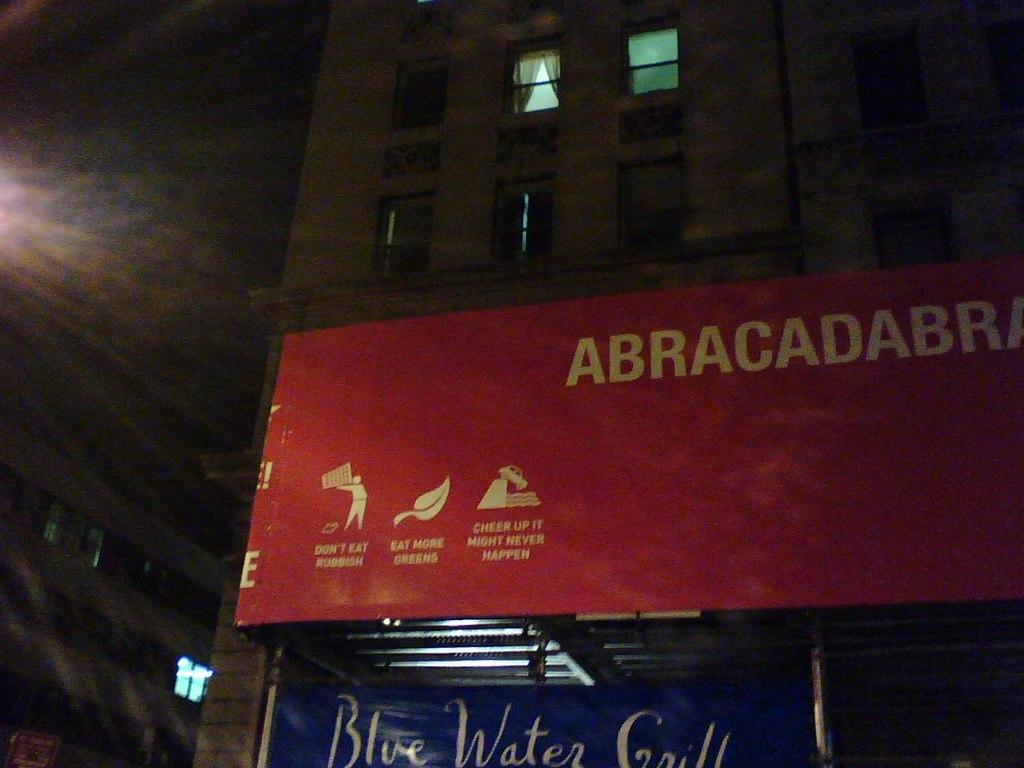What color is the water grill?
Your response must be concise. Blue. What are the three things on the bottom left corner that the red billboard tells you?
Offer a terse response. Don't eat rubbish, eat more greens, cheer up it might never happen. 